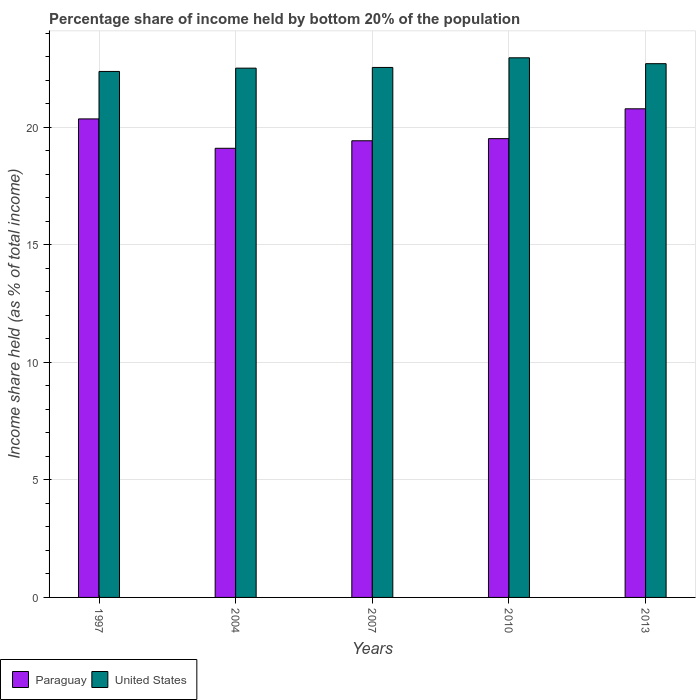Are the number of bars per tick equal to the number of legend labels?
Your response must be concise. Yes. In how many cases, is the number of bars for a given year not equal to the number of legend labels?
Give a very brief answer. 0. What is the share of income held by bottom 20% of the population in Paraguay in 1997?
Keep it short and to the point. 20.36. Across all years, what is the maximum share of income held by bottom 20% of the population in United States?
Your answer should be very brief. 22.96. Across all years, what is the minimum share of income held by bottom 20% of the population in United States?
Your answer should be very brief. 22.38. In which year was the share of income held by bottom 20% of the population in Paraguay maximum?
Provide a short and direct response. 2013. In which year was the share of income held by bottom 20% of the population in Paraguay minimum?
Keep it short and to the point. 2004. What is the total share of income held by bottom 20% of the population in United States in the graph?
Offer a terse response. 113.12. What is the difference between the share of income held by bottom 20% of the population in United States in 2004 and that in 2010?
Give a very brief answer. -0.44. What is the difference between the share of income held by bottom 20% of the population in United States in 2010 and the share of income held by bottom 20% of the population in Paraguay in 2013?
Your answer should be compact. 2.17. What is the average share of income held by bottom 20% of the population in United States per year?
Provide a short and direct response. 22.62. In the year 1997, what is the difference between the share of income held by bottom 20% of the population in Paraguay and share of income held by bottom 20% of the population in United States?
Your response must be concise. -2.02. What is the ratio of the share of income held by bottom 20% of the population in Paraguay in 2004 to that in 2013?
Keep it short and to the point. 0.92. Is the share of income held by bottom 20% of the population in Paraguay in 2004 less than that in 2013?
Give a very brief answer. Yes. What is the difference between the highest and the second highest share of income held by bottom 20% of the population in United States?
Your answer should be very brief. 0.25. What is the difference between the highest and the lowest share of income held by bottom 20% of the population in Paraguay?
Your answer should be very brief. 1.68. In how many years, is the share of income held by bottom 20% of the population in United States greater than the average share of income held by bottom 20% of the population in United States taken over all years?
Provide a short and direct response. 2. What does the 1st bar from the left in 1997 represents?
Your response must be concise. Paraguay. What does the 2nd bar from the right in 2010 represents?
Make the answer very short. Paraguay. Are all the bars in the graph horizontal?
Ensure brevity in your answer.  No. How many years are there in the graph?
Your answer should be compact. 5. What is the difference between two consecutive major ticks on the Y-axis?
Keep it short and to the point. 5. Does the graph contain grids?
Your answer should be compact. Yes. Where does the legend appear in the graph?
Ensure brevity in your answer.  Bottom left. What is the title of the graph?
Make the answer very short. Percentage share of income held by bottom 20% of the population. What is the label or title of the Y-axis?
Give a very brief answer. Income share held (as % of total income). What is the Income share held (as % of total income) of Paraguay in 1997?
Your answer should be compact. 20.36. What is the Income share held (as % of total income) in United States in 1997?
Offer a very short reply. 22.38. What is the Income share held (as % of total income) of Paraguay in 2004?
Your answer should be compact. 19.11. What is the Income share held (as % of total income) of United States in 2004?
Your answer should be very brief. 22.52. What is the Income share held (as % of total income) in Paraguay in 2007?
Your answer should be compact. 19.43. What is the Income share held (as % of total income) of United States in 2007?
Your response must be concise. 22.55. What is the Income share held (as % of total income) in Paraguay in 2010?
Ensure brevity in your answer.  19.52. What is the Income share held (as % of total income) of United States in 2010?
Offer a very short reply. 22.96. What is the Income share held (as % of total income) of Paraguay in 2013?
Your response must be concise. 20.79. What is the Income share held (as % of total income) of United States in 2013?
Keep it short and to the point. 22.71. Across all years, what is the maximum Income share held (as % of total income) of Paraguay?
Make the answer very short. 20.79. Across all years, what is the maximum Income share held (as % of total income) in United States?
Your response must be concise. 22.96. Across all years, what is the minimum Income share held (as % of total income) in Paraguay?
Your answer should be very brief. 19.11. Across all years, what is the minimum Income share held (as % of total income) of United States?
Keep it short and to the point. 22.38. What is the total Income share held (as % of total income) of Paraguay in the graph?
Offer a very short reply. 99.21. What is the total Income share held (as % of total income) of United States in the graph?
Your answer should be very brief. 113.12. What is the difference between the Income share held (as % of total income) of Paraguay in 1997 and that in 2004?
Offer a very short reply. 1.25. What is the difference between the Income share held (as % of total income) in United States in 1997 and that in 2004?
Make the answer very short. -0.14. What is the difference between the Income share held (as % of total income) of Paraguay in 1997 and that in 2007?
Offer a terse response. 0.93. What is the difference between the Income share held (as % of total income) of United States in 1997 and that in 2007?
Ensure brevity in your answer.  -0.17. What is the difference between the Income share held (as % of total income) of Paraguay in 1997 and that in 2010?
Your response must be concise. 0.84. What is the difference between the Income share held (as % of total income) of United States in 1997 and that in 2010?
Provide a succinct answer. -0.58. What is the difference between the Income share held (as % of total income) in Paraguay in 1997 and that in 2013?
Your response must be concise. -0.43. What is the difference between the Income share held (as % of total income) in United States in 1997 and that in 2013?
Offer a very short reply. -0.33. What is the difference between the Income share held (as % of total income) of Paraguay in 2004 and that in 2007?
Ensure brevity in your answer.  -0.32. What is the difference between the Income share held (as % of total income) of United States in 2004 and that in 2007?
Provide a short and direct response. -0.03. What is the difference between the Income share held (as % of total income) of Paraguay in 2004 and that in 2010?
Provide a short and direct response. -0.41. What is the difference between the Income share held (as % of total income) of United States in 2004 and that in 2010?
Ensure brevity in your answer.  -0.44. What is the difference between the Income share held (as % of total income) of Paraguay in 2004 and that in 2013?
Your response must be concise. -1.68. What is the difference between the Income share held (as % of total income) of United States in 2004 and that in 2013?
Make the answer very short. -0.19. What is the difference between the Income share held (as % of total income) in Paraguay in 2007 and that in 2010?
Keep it short and to the point. -0.09. What is the difference between the Income share held (as % of total income) in United States in 2007 and that in 2010?
Your answer should be compact. -0.41. What is the difference between the Income share held (as % of total income) of Paraguay in 2007 and that in 2013?
Keep it short and to the point. -1.36. What is the difference between the Income share held (as % of total income) of United States in 2007 and that in 2013?
Your answer should be compact. -0.16. What is the difference between the Income share held (as % of total income) of Paraguay in 2010 and that in 2013?
Make the answer very short. -1.27. What is the difference between the Income share held (as % of total income) of Paraguay in 1997 and the Income share held (as % of total income) of United States in 2004?
Provide a succinct answer. -2.16. What is the difference between the Income share held (as % of total income) in Paraguay in 1997 and the Income share held (as % of total income) in United States in 2007?
Offer a very short reply. -2.19. What is the difference between the Income share held (as % of total income) in Paraguay in 1997 and the Income share held (as % of total income) in United States in 2010?
Keep it short and to the point. -2.6. What is the difference between the Income share held (as % of total income) of Paraguay in 1997 and the Income share held (as % of total income) of United States in 2013?
Offer a very short reply. -2.35. What is the difference between the Income share held (as % of total income) in Paraguay in 2004 and the Income share held (as % of total income) in United States in 2007?
Your answer should be very brief. -3.44. What is the difference between the Income share held (as % of total income) in Paraguay in 2004 and the Income share held (as % of total income) in United States in 2010?
Ensure brevity in your answer.  -3.85. What is the difference between the Income share held (as % of total income) of Paraguay in 2004 and the Income share held (as % of total income) of United States in 2013?
Give a very brief answer. -3.6. What is the difference between the Income share held (as % of total income) in Paraguay in 2007 and the Income share held (as % of total income) in United States in 2010?
Your response must be concise. -3.53. What is the difference between the Income share held (as % of total income) in Paraguay in 2007 and the Income share held (as % of total income) in United States in 2013?
Ensure brevity in your answer.  -3.28. What is the difference between the Income share held (as % of total income) of Paraguay in 2010 and the Income share held (as % of total income) of United States in 2013?
Give a very brief answer. -3.19. What is the average Income share held (as % of total income) in Paraguay per year?
Ensure brevity in your answer.  19.84. What is the average Income share held (as % of total income) of United States per year?
Your answer should be compact. 22.62. In the year 1997, what is the difference between the Income share held (as % of total income) of Paraguay and Income share held (as % of total income) of United States?
Your answer should be compact. -2.02. In the year 2004, what is the difference between the Income share held (as % of total income) of Paraguay and Income share held (as % of total income) of United States?
Offer a terse response. -3.41. In the year 2007, what is the difference between the Income share held (as % of total income) in Paraguay and Income share held (as % of total income) in United States?
Offer a terse response. -3.12. In the year 2010, what is the difference between the Income share held (as % of total income) in Paraguay and Income share held (as % of total income) in United States?
Make the answer very short. -3.44. In the year 2013, what is the difference between the Income share held (as % of total income) in Paraguay and Income share held (as % of total income) in United States?
Provide a short and direct response. -1.92. What is the ratio of the Income share held (as % of total income) of Paraguay in 1997 to that in 2004?
Your response must be concise. 1.07. What is the ratio of the Income share held (as % of total income) in Paraguay in 1997 to that in 2007?
Ensure brevity in your answer.  1.05. What is the ratio of the Income share held (as % of total income) in Paraguay in 1997 to that in 2010?
Your answer should be compact. 1.04. What is the ratio of the Income share held (as % of total income) in United States in 1997 to that in 2010?
Offer a terse response. 0.97. What is the ratio of the Income share held (as % of total income) in Paraguay in 1997 to that in 2013?
Keep it short and to the point. 0.98. What is the ratio of the Income share held (as % of total income) in United States in 1997 to that in 2013?
Provide a short and direct response. 0.99. What is the ratio of the Income share held (as % of total income) of Paraguay in 2004 to that in 2007?
Provide a short and direct response. 0.98. What is the ratio of the Income share held (as % of total income) of United States in 2004 to that in 2007?
Ensure brevity in your answer.  1. What is the ratio of the Income share held (as % of total income) in United States in 2004 to that in 2010?
Your response must be concise. 0.98. What is the ratio of the Income share held (as % of total income) of Paraguay in 2004 to that in 2013?
Provide a short and direct response. 0.92. What is the ratio of the Income share held (as % of total income) of United States in 2007 to that in 2010?
Keep it short and to the point. 0.98. What is the ratio of the Income share held (as % of total income) in Paraguay in 2007 to that in 2013?
Your answer should be very brief. 0.93. What is the ratio of the Income share held (as % of total income) in Paraguay in 2010 to that in 2013?
Your response must be concise. 0.94. What is the difference between the highest and the second highest Income share held (as % of total income) of Paraguay?
Offer a very short reply. 0.43. What is the difference between the highest and the lowest Income share held (as % of total income) in Paraguay?
Offer a very short reply. 1.68. What is the difference between the highest and the lowest Income share held (as % of total income) of United States?
Offer a very short reply. 0.58. 